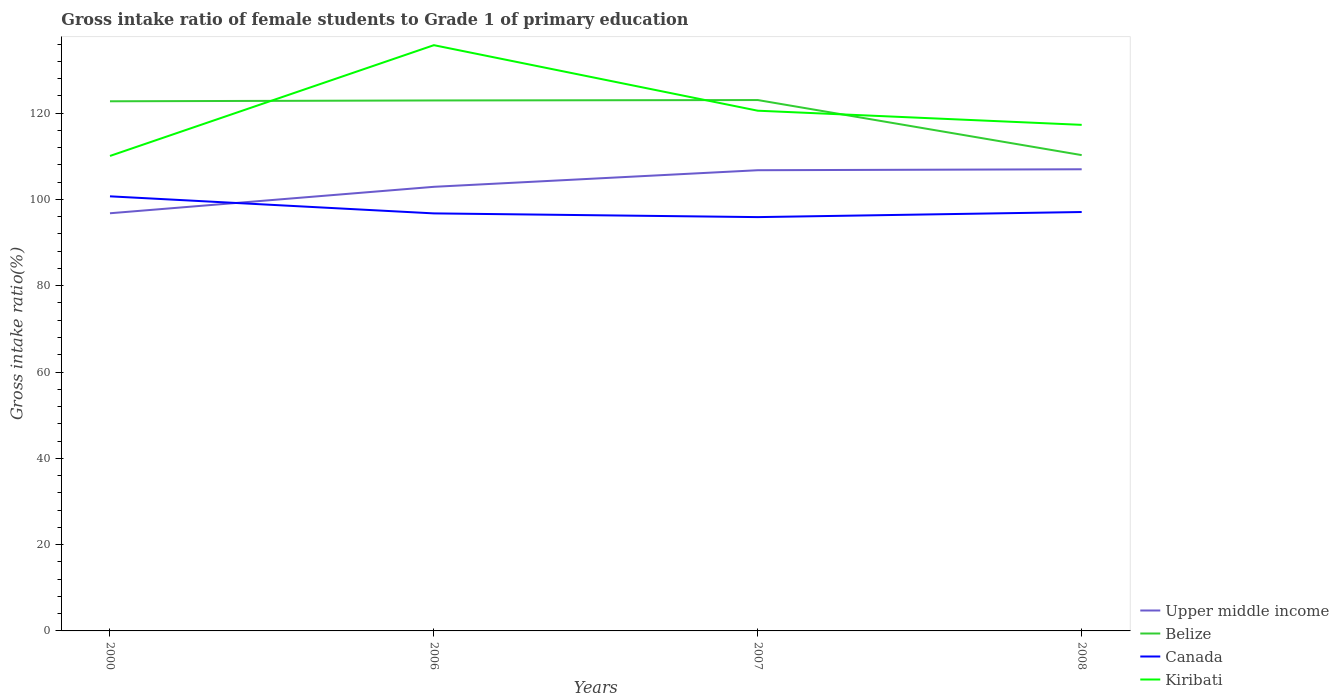How many different coloured lines are there?
Your response must be concise. 4. Does the line corresponding to Belize intersect with the line corresponding to Canada?
Ensure brevity in your answer.  No. Is the number of lines equal to the number of legend labels?
Your response must be concise. Yes. Across all years, what is the maximum gross intake ratio in Belize?
Provide a short and direct response. 110.27. In which year was the gross intake ratio in Canada maximum?
Keep it short and to the point. 2007. What is the total gross intake ratio in Belize in the graph?
Ensure brevity in your answer.  -0.29. What is the difference between the highest and the second highest gross intake ratio in Upper middle income?
Your response must be concise. 10.2. How many lines are there?
Provide a short and direct response. 4. What is the difference between two consecutive major ticks on the Y-axis?
Your answer should be compact. 20. Are the values on the major ticks of Y-axis written in scientific E-notation?
Your answer should be very brief. No. Does the graph contain grids?
Provide a short and direct response. No. How many legend labels are there?
Ensure brevity in your answer.  4. What is the title of the graph?
Ensure brevity in your answer.  Gross intake ratio of female students to Grade 1 of primary education. Does "Aruba" appear as one of the legend labels in the graph?
Ensure brevity in your answer.  No. What is the label or title of the Y-axis?
Provide a succinct answer. Gross intake ratio(%). What is the Gross intake ratio(%) in Upper middle income in 2000?
Offer a terse response. 96.8. What is the Gross intake ratio(%) of Belize in 2000?
Offer a terse response. 122.75. What is the Gross intake ratio(%) of Canada in 2000?
Offer a very short reply. 100.72. What is the Gross intake ratio(%) in Kiribati in 2000?
Provide a short and direct response. 110.08. What is the Gross intake ratio(%) in Upper middle income in 2006?
Offer a very short reply. 102.93. What is the Gross intake ratio(%) of Belize in 2006?
Give a very brief answer. 122.94. What is the Gross intake ratio(%) of Canada in 2006?
Keep it short and to the point. 96.76. What is the Gross intake ratio(%) in Kiribati in 2006?
Keep it short and to the point. 135.75. What is the Gross intake ratio(%) in Upper middle income in 2007?
Provide a short and direct response. 106.77. What is the Gross intake ratio(%) in Belize in 2007?
Offer a very short reply. 123.03. What is the Gross intake ratio(%) of Canada in 2007?
Make the answer very short. 95.91. What is the Gross intake ratio(%) in Kiribati in 2007?
Offer a terse response. 120.56. What is the Gross intake ratio(%) in Upper middle income in 2008?
Offer a very short reply. 106.99. What is the Gross intake ratio(%) in Belize in 2008?
Provide a succinct answer. 110.27. What is the Gross intake ratio(%) in Canada in 2008?
Make the answer very short. 97.09. What is the Gross intake ratio(%) in Kiribati in 2008?
Provide a short and direct response. 117.29. Across all years, what is the maximum Gross intake ratio(%) in Upper middle income?
Provide a succinct answer. 106.99. Across all years, what is the maximum Gross intake ratio(%) of Belize?
Offer a very short reply. 123.03. Across all years, what is the maximum Gross intake ratio(%) in Canada?
Keep it short and to the point. 100.72. Across all years, what is the maximum Gross intake ratio(%) in Kiribati?
Your answer should be very brief. 135.75. Across all years, what is the minimum Gross intake ratio(%) of Upper middle income?
Give a very brief answer. 96.8. Across all years, what is the minimum Gross intake ratio(%) of Belize?
Provide a short and direct response. 110.27. Across all years, what is the minimum Gross intake ratio(%) of Canada?
Your answer should be very brief. 95.91. Across all years, what is the minimum Gross intake ratio(%) in Kiribati?
Offer a terse response. 110.08. What is the total Gross intake ratio(%) in Upper middle income in the graph?
Provide a succinct answer. 413.49. What is the total Gross intake ratio(%) of Belize in the graph?
Provide a succinct answer. 479. What is the total Gross intake ratio(%) in Canada in the graph?
Provide a succinct answer. 390.48. What is the total Gross intake ratio(%) of Kiribati in the graph?
Provide a succinct answer. 483.68. What is the difference between the Gross intake ratio(%) in Upper middle income in 2000 and that in 2006?
Offer a very short reply. -6.13. What is the difference between the Gross intake ratio(%) of Belize in 2000 and that in 2006?
Keep it short and to the point. -0.2. What is the difference between the Gross intake ratio(%) in Canada in 2000 and that in 2006?
Keep it short and to the point. 3.95. What is the difference between the Gross intake ratio(%) of Kiribati in 2000 and that in 2006?
Provide a short and direct response. -25.67. What is the difference between the Gross intake ratio(%) in Upper middle income in 2000 and that in 2007?
Offer a terse response. -9.97. What is the difference between the Gross intake ratio(%) of Belize in 2000 and that in 2007?
Provide a short and direct response. -0.29. What is the difference between the Gross intake ratio(%) of Canada in 2000 and that in 2007?
Offer a terse response. 4.81. What is the difference between the Gross intake ratio(%) of Kiribati in 2000 and that in 2007?
Make the answer very short. -10.48. What is the difference between the Gross intake ratio(%) in Upper middle income in 2000 and that in 2008?
Offer a terse response. -10.2. What is the difference between the Gross intake ratio(%) of Belize in 2000 and that in 2008?
Offer a terse response. 12.47. What is the difference between the Gross intake ratio(%) in Canada in 2000 and that in 2008?
Offer a terse response. 3.63. What is the difference between the Gross intake ratio(%) in Kiribati in 2000 and that in 2008?
Your response must be concise. -7.21. What is the difference between the Gross intake ratio(%) in Upper middle income in 2006 and that in 2007?
Offer a terse response. -3.85. What is the difference between the Gross intake ratio(%) in Belize in 2006 and that in 2007?
Offer a very short reply. -0.09. What is the difference between the Gross intake ratio(%) of Canada in 2006 and that in 2007?
Offer a very short reply. 0.86. What is the difference between the Gross intake ratio(%) in Kiribati in 2006 and that in 2007?
Your answer should be compact. 15.19. What is the difference between the Gross intake ratio(%) in Upper middle income in 2006 and that in 2008?
Keep it short and to the point. -4.07. What is the difference between the Gross intake ratio(%) in Belize in 2006 and that in 2008?
Your answer should be very brief. 12.67. What is the difference between the Gross intake ratio(%) of Canada in 2006 and that in 2008?
Offer a terse response. -0.32. What is the difference between the Gross intake ratio(%) in Kiribati in 2006 and that in 2008?
Provide a succinct answer. 18.47. What is the difference between the Gross intake ratio(%) of Upper middle income in 2007 and that in 2008?
Your answer should be very brief. -0.22. What is the difference between the Gross intake ratio(%) of Belize in 2007 and that in 2008?
Provide a short and direct response. 12.76. What is the difference between the Gross intake ratio(%) in Canada in 2007 and that in 2008?
Your answer should be compact. -1.18. What is the difference between the Gross intake ratio(%) of Kiribati in 2007 and that in 2008?
Provide a short and direct response. 3.28. What is the difference between the Gross intake ratio(%) in Upper middle income in 2000 and the Gross intake ratio(%) in Belize in 2006?
Ensure brevity in your answer.  -26.15. What is the difference between the Gross intake ratio(%) of Upper middle income in 2000 and the Gross intake ratio(%) of Canada in 2006?
Give a very brief answer. 0.03. What is the difference between the Gross intake ratio(%) of Upper middle income in 2000 and the Gross intake ratio(%) of Kiribati in 2006?
Provide a short and direct response. -38.96. What is the difference between the Gross intake ratio(%) of Belize in 2000 and the Gross intake ratio(%) of Canada in 2006?
Your answer should be very brief. 25.98. What is the difference between the Gross intake ratio(%) in Belize in 2000 and the Gross intake ratio(%) in Kiribati in 2006?
Make the answer very short. -13.01. What is the difference between the Gross intake ratio(%) of Canada in 2000 and the Gross intake ratio(%) of Kiribati in 2006?
Provide a short and direct response. -35.03. What is the difference between the Gross intake ratio(%) in Upper middle income in 2000 and the Gross intake ratio(%) in Belize in 2007?
Ensure brevity in your answer.  -26.24. What is the difference between the Gross intake ratio(%) in Upper middle income in 2000 and the Gross intake ratio(%) in Canada in 2007?
Keep it short and to the point. 0.89. What is the difference between the Gross intake ratio(%) in Upper middle income in 2000 and the Gross intake ratio(%) in Kiribati in 2007?
Ensure brevity in your answer.  -23.77. What is the difference between the Gross intake ratio(%) in Belize in 2000 and the Gross intake ratio(%) in Canada in 2007?
Give a very brief answer. 26.84. What is the difference between the Gross intake ratio(%) of Belize in 2000 and the Gross intake ratio(%) of Kiribati in 2007?
Make the answer very short. 2.18. What is the difference between the Gross intake ratio(%) of Canada in 2000 and the Gross intake ratio(%) of Kiribati in 2007?
Your answer should be compact. -19.84. What is the difference between the Gross intake ratio(%) of Upper middle income in 2000 and the Gross intake ratio(%) of Belize in 2008?
Make the answer very short. -13.48. What is the difference between the Gross intake ratio(%) in Upper middle income in 2000 and the Gross intake ratio(%) in Canada in 2008?
Ensure brevity in your answer.  -0.29. What is the difference between the Gross intake ratio(%) in Upper middle income in 2000 and the Gross intake ratio(%) in Kiribati in 2008?
Give a very brief answer. -20.49. What is the difference between the Gross intake ratio(%) in Belize in 2000 and the Gross intake ratio(%) in Canada in 2008?
Provide a succinct answer. 25.66. What is the difference between the Gross intake ratio(%) in Belize in 2000 and the Gross intake ratio(%) in Kiribati in 2008?
Make the answer very short. 5.46. What is the difference between the Gross intake ratio(%) of Canada in 2000 and the Gross intake ratio(%) of Kiribati in 2008?
Keep it short and to the point. -16.57. What is the difference between the Gross intake ratio(%) of Upper middle income in 2006 and the Gross intake ratio(%) of Belize in 2007?
Make the answer very short. -20.11. What is the difference between the Gross intake ratio(%) of Upper middle income in 2006 and the Gross intake ratio(%) of Canada in 2007?
Provide a succinct answer. 7.02. What is the difference between the Gross intake ratio(%) of Upper middle income in 2006 and the Gross intake ratio(%) of Kiribati in 2007?
Your answer should be very brief. -17.64. What is the difference between the Gross intake ratio(%) in Belize in 2006 and the Gross intake ratio(%) in Canada in 2007?
Provide a short and direct response. 27.04. What is the difference between the Gross intake ratio(%) of Belize in 2006 and the Gross intake ratio(%) of Kiribati in 2007?
Ensure brevity in your answer.  2.38. What is the difference between the Gross intake ratio(%) in Canada in 2006 and the Gross intake ratio(%) in Kiribati in 2007?
Keep it short and to the point. -23.8. What is the difference between the Gross intake ratio(%) of Upper middle income in 2006 and the Gross intake ratio(%) of Belize in 2008?
Provide a short and direct response. -7.35. What is the difference between the Gross intake ratio(%) in Upper middle income in 2006 and the Gross intake ratio(%) in Canada in 2008?
Provide a short and direct response. 5.84. What is the difference between the Gross intake ratio(%) in Upper middle income in 2006 and the Gross intake ratio(%) in Kiribati in 2008?
Your answer should be compact. -14.36. What is the difference between the Gross intake ratio(%) of Belize in 2006 and the Gross intake ratio(%) of Canada in 2008?
Keep it short and to the point. 25.86. What is the difference between the Gross intake ratio(%) of Belize in 2006 and the Gross intake ratio(%) of Kiribati in 2008?
Provide a short and direct response. 5.66. What is the difference between the Gross intake ratio(%) of Canada in 2006 and the Gross intake ratio(%) of Kiribati in 2008?
Provide a succinct answer. -20.52. What is the difference between the Gross intake ratio(%) of Upper middle income in 2007 and the Gross intake ratio(%) of Belize in 2008?
Give a very brief answer. -3.5. What is the difference between the Gross intake ratio(%) of Upper middle income in 2007 and the Gross intake ratio(%) of Canada in 2008?
Your answer should be compact. 9.69. What is the difference between the Gross intake ratio(%) in Upper middle income in 2007 and the Gross intake ratio(%) in Kiribati in 2008?
Offer a very short reply. -10.51. What is the difference between the Gross intake ratio(%) in Belize in 2007 and the Gross intake ratio(%) in Canada in 2008?
Offer a terse response. 25.95. What is the difference between the Gross intake ratio(%) in Belize in 2007 and the Gross intake ratio(%) in Kiribati in 2008?
Provide a succinct answer. 5.75. What is the difference between the Gross intake ratio(%) in Canada in 2007 and the Gross intake ratio(%) in Kiribati in 2008?
Keep it short and to the point. -21.38. What is the average Gross intake ratio(%) of Upper middle income per year?
Your answer should be compact. 103.37. What is the average Gross intake ratio(%) of Belize per year?
Ensure brevity in your answer.  119.75. What is the average Gross intake ratio(%) of Canada per year?
Offer a very short reply. 97.62. What is the average Gross intake ratio(%) in Kiribati per year?
Make the answer very short. 120.92. In the year 2000, what is the difference between the Gross intake ratio(%) in Upper middle income and Gross intake ratio(%) in Belize?
Keep it short and to the point. -25.95. In the year 2000, what is the difference between the Gross intake ratio(%) in Upper middle income and Gross intake ratio(%) in Canada?
Keep it short and to the point. -3.92. In the year 2000, what is the difference between the Gross intake ratio(%) of Upper middle income and Gross intake ratio(%) of Kiribati?
Provide a succinct answer. -13.28. In the year 2000, what is the difference between the Gross intake ratio(%) in Belize and Gross intake ratio(%) in Canada?
Offer a terse response. 22.03. In the year 2000, what is the difference between the Gross intake ratio(%) of Belize and Gross intake ratio(%) of Kiribati?
Offer a very short reply. 12.67. In the year 2000, what is the difference between the Gross intake ratio(%) in Canada and Gross intake ratio(%) in Kiribati?
Offer a terse response. -9.36. In the year 2006, what is the difference between the Gross intake ratio(%) in Upper middle income and Gross intake ratio(%) in Belize?
Your answer should be very brief. -20.02. In the year 2006, what is the difference between the Gross intake ratio(%) in Upper middle income and Gross intake ratio(%) in Canada?
Your response must be concise. 6.16. In the year 2006, what is the difference between the Gross intake ratio(%) of Upper middle income and Gross intake ratio(%) of Kiribati?
Provide a short and direct response. -32.83. In the year 2006, what is the difference between the Gross intake ratio(%) in Belize and Gross intake ratio(%) in Canada?
Give a very brief answer. 26.18. In the year 2006, what is the difference between the Gross intake ratio(%) of Belize and Gross intake ratio(%) of Kiribati?
Your answer should be very brief. -12.81. In the year 2006, what is the difference between the Gross intake ratio(%) in Canada and Gross intake ratio(%) in Kiribati?
Ensure brevity in your answer.  -38.99. In the year 2007, what is the difference between the Gross intake ratio(%) in Upper middle income and Gross intake ratio(%) in Belize?
Provide a short and direct response. -16.26. In the year 2007, what is the difference between the Gross intake ratio(%) of Upper middle income and Gross intake ratio(%) of Canada?
Your answer should be compact. 10.87. In the year 2007, what is the difference between the Gross intake ratio(%) in Upper middle income and Gross intake ratio(%) in Kiribati?
Keep it short and to the point. -13.79. In the year 2007, what is the difference between the Gross intake ratio(%) in Belize and Gross intake ratio(%) in Canada?
Make the answer very short. 27.13. In the year 2007, what is the difference between the Gross intake ratio(%) of Belize and Gross intake ratio(%) of Kiribati?
Provide a short and direct response. 2.47. In the year 2007, what is the difference between the Gross intake ratio(%) of Canada and Gross intake ratio(%) of Kiribati?
Your answer should be very brief. -24.66. In the year 2008, what is the difference between the Gross intake ratio(%) in Upper middle income and Gross intake ratio(%) in Belize?
Offer a very short reply. -3.28. In the year 2008, what is the difference between the Gross intake ratio(%) in Upper middle income and Gross intake ratio(%) in Canada?
Keep it short and to the point. 9.91. In the year 2008, what is the difference between the Gross intake ratio(%) in Upper middle income and Gross intake ratio(%) in Kiribati?
Offer a very short reply. -10.29. In the year 2008, what is the difference between the Gross intake ratio(%) of Belize and Gross intake ratio(%) of Canada?
Your answer should be compact. 13.19. In the year 2008, what is the difference between the Gross intake ratio(%) in Belize and Gross intake ratio(%) in Kiribati?
Your answer should be compact. -7.01. In the year 2008, what is the difference between the Gross intake ratio(%) in Canada and Gross intake ratio(%) in Kiribati?
Offer a terse response. -20.2. What is the ratio of the Gross intake ratio(%) in Upper middle income in 2000 to that in 2006?
Provide a short and direct response. 0.94. What is the ratio of the Gross intake ratio(%) of Canada in 2000 to that in 2006?
Keep it short and to the point. 1.04. What is the ratio of the Gross intake ratio(%) of Kiribati in 2000 to that in 2006?
Give a very brief answer. 0.81. What is the ratio of the Gross intake ratio(%) in Upper middle income in 2000 to that in 2007?
Keep it short and to the point. 0.91. What is the ratio of the Gross intake ratio(%) in Canada in 2000 to that in 2007?
Your answer should be very brief. 1.05. What is the ratio of the Gross intake ratio(%) of Upper middle income in 2000 to that in 2008?
Your answer should be very brief. 0.9. What is the ratio of the Gross intake ratio(%) of Belize in 2000 to that in 2008?
Keep it short and to the point. 1.11. What is the ratio of the Gross intake ratio(%) of Canada in 2000 to that in 2008?
Make the answer very short. 1.04. What is the ratio of the Gross intake ratio(%) of Kiribati in 2000 to that in 2008?
Make the answer very short. 0.94. What is the ratio of the Gross intake ratio(%) of Upper middle income in 2006 to that in 2007?
Provide a short and direct response. 0.96. What is the ratio of the Gross intake ratio(%) of Belize in 2006 to that in 2007?
Your response must be concise. 1. What is the ratio of the Gross intake ratio(%) in Kiribati in 2006 to that in 2007?
Your answer should be very brief. 1.13. What is the ratio of the Gross intake ratio(%) in Upper middle income in 2006 to that in 2008?
Provide a succinct answer. 0.96. What is the ratio of the Gross intake ratio(%) of Belize in 2006 to that in 2008?
Provide a succinct answer. 1.11. What is the ratio of the Gross intake ratio(%) of Kiribati in 2006 to that in 2008?
Give a very brief answer. 1.16. What is the ratio of the Gross intake ratio(%) in Belize in 2007 to that in 2008?
Your answer should be very brief. 1.12. What is the ratio of the Gross intake ratio(%) in Canada in 2007 to that in 2008?
Provide a short and direct response. 0.99. What is the ratio of the Gross intake ratio(%) in Kiribati in 2007 to that in 2008?
Give a very brief answer. 1.03. What is the difference between the highest and the second highest Gross intake ratio(%) in Upper middle income?
Keep it short and to the point. 0.22. What is the difference between the highest and the second highest Gross intake ratio(%) of Belize?
Your answer should be very brief. 0.09. What is the difference between the highest and the second highest Gross intake ratio(%) of Canada?
Offer a terse response. 3.63. What is the difference between the highest and the second highest Gross intake ratio(%) of Kiribati?
Your response must be concise. 15.19. What is the difference between the highest and the lowest Gross intake ratio(%) in Upper middle income?
Offer a very short reply. 10.2. What is the difference between the highest and the lowest Gross intake ratio(%) of Belize?
Give a very brief answer. 12.76. What is the difference between the highest and the lowest Gross intake ratio(%) of Canada?
Provide a succinct answer. 4.81. What is the difference between the highest and the lowest Gross intake ratio(%) in Kiribati?
Make the answer very short. 25.67. 